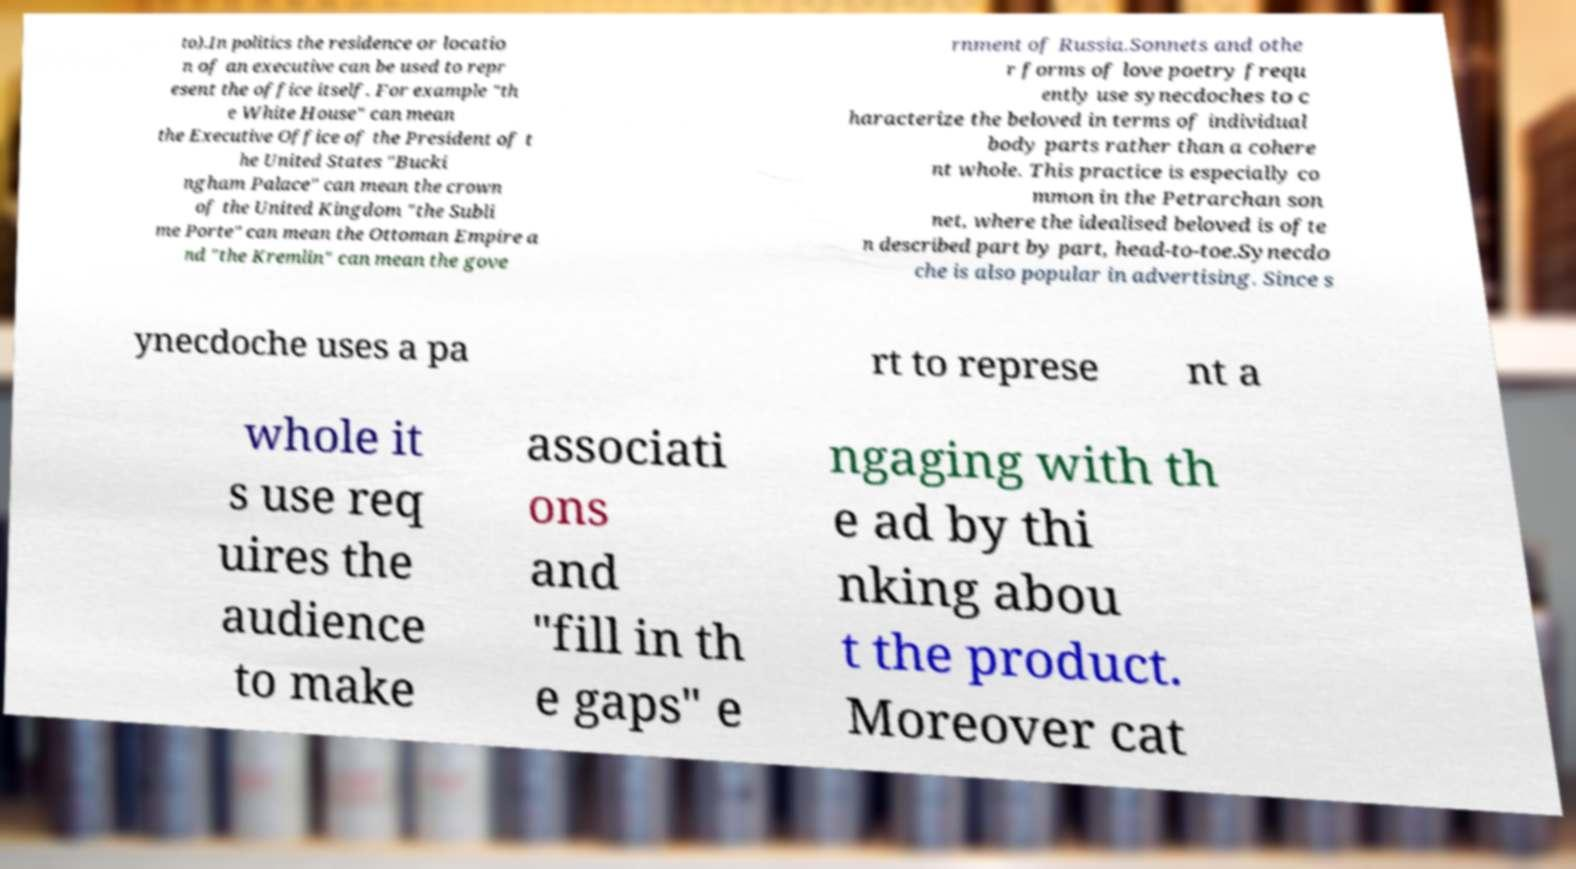For documentation purposes, I need the text within this image transcribed. Could you provide that? to).In politics the residence or locatio n of an executive can be used to repr esent the office itself. For example "th e White House" can mean the Executive Office of the President of t he United States "Bucki ngham Palace" can mean the crown of the United Kingdom "the Subli me Porte" can mean the Ottoman Empire a nd "the Kremlin" can mean the gove rnment of Russia.Sonnets and othe r forms of love poetry frequ ently use synecdoches to c haracterize the beloved in terms of individual body parts rather than a cohere nt whole. This practice is especially co mmon in the Petrarchan son net, where the idealised beloved is ofte n described part by part, head-to-toe.Synecdo che is also popular in advertising. Since s ynecdoche uses a pa rt to represe nt a whole it s use req uires the audience to make associati ons and "fill in th e gaps" e ngaging with th e ad by thi nking abou t the product. Moreover cat 